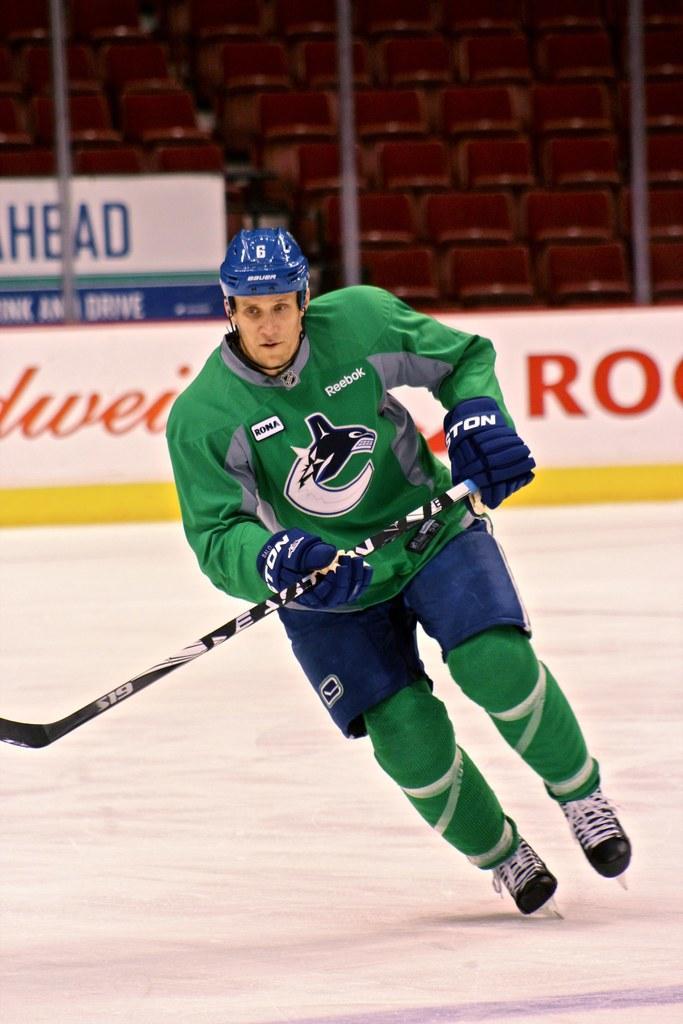Can you describe this image briefly? In this image I can see a person wearing green, blue and grey colored dress is skiing on the snow and I can see he is holding a hockey stick which is black and white in color. I can see he is wearing blue colored helmet. In the background I can see the banner which is white in color and few seats which are red in color in the stadium. 